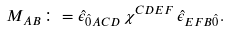Convert formula to latex. <formula><loc_0><loc_0><loc_500><loc_500>M _ { A B } \colon = \hat { \epsilon } _ { \hat { 0 } A C D } \, \chi ^ { C D E F } \, \hat { \epsilon } _ { E F B \hat { 0 } } .</formula> 